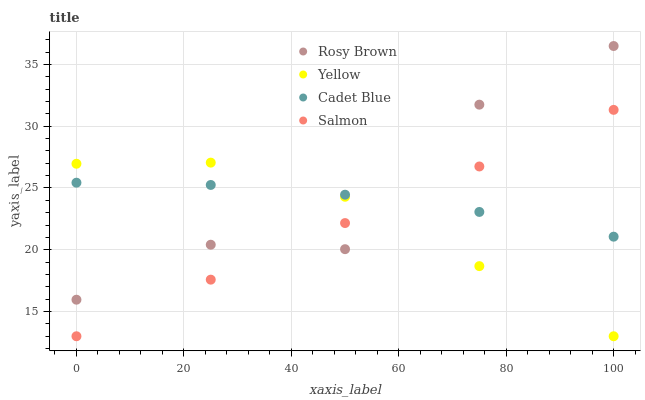Does Salmon have the minimum area under the curve?
Answer yes or no. Yes. Does Rosy Brown have the maximum area under the curve?
Answer yes or no. Yes. Does Rosy Brown have the minimum area under the curve?
Answer yes or no. No. Does Salmon have the maximum area under the curve?
Answer yes or no. No. Is Salmon the smoothest?
Answer yes or no. Yes. Is Rosy Brown the roughest?
Answer yes or no. Yes. Is Rosy Brown the smoothest?
Answer yes or no. No. Is Salmon the roughest?
Answer yes or no. No. Does Salmon have the lowest value?
Answer yes or no. Yes. Does Rosy Brown have the lowest value?
Answer yes or no. No. Does Rosy Brown have the highest value?
Answer yes or no. Yes. Does Salmon have the highest value?
Answer yes or no. No. Does Cadet Blue intersect Rosy Brown?
Answer yes or no. Yes. Is Cadet Blue less than Rosy Brown?
Answer yes or no. No. Is Cadet Blue greater than Rosy Brown?
Answer yes or no. No. 